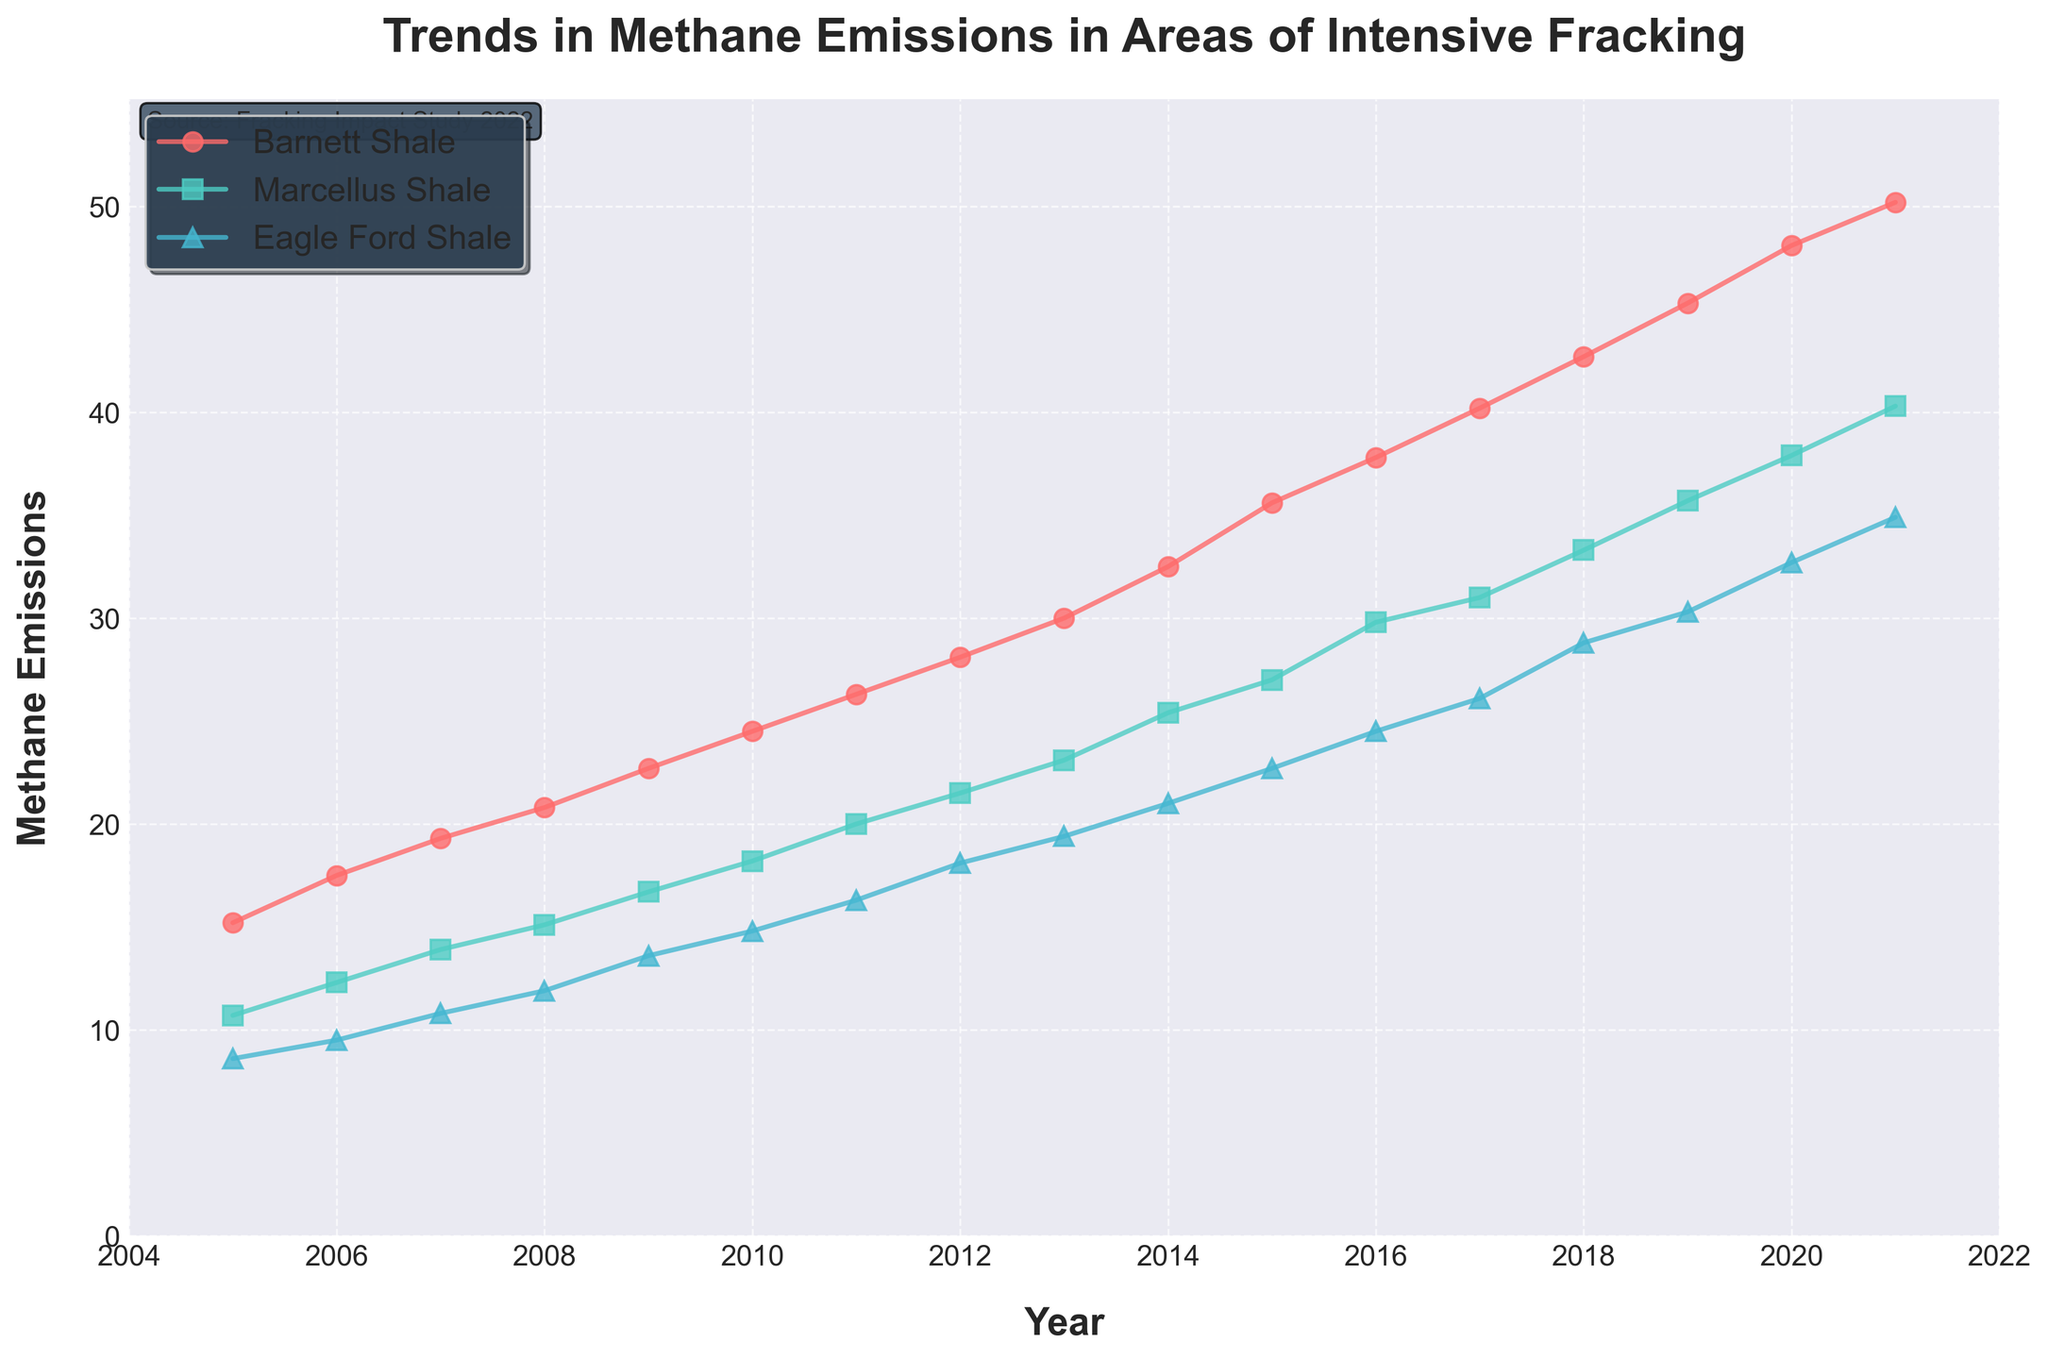What is the title of the plot? The title is located at the top center of the figure and is typically the most prominent text.
Answer: Trends in Methane Emissions in Areas of Intensive Fracking What are the x-axis and y-axis labels? The x-axis and y-axis labels are usually located beside the respective axes. They describe what each axis represents.
Answer: Year and Methane Emissions How does the methane emission trend for the Barnett Shale region change from 2005 to 2021? The trend for methane emissions in the Barnett Shale region can be observed by looking at the data points and the line connecting them. The emissions increase steadily every year.
Answer: It increases continuously Which region had the highest methane emissions in 2021? To determine which region had the highest methane emissions in 2021, compare the end points of each line representing each region on the plot. The Barnett Shale region shows the highest value at 2021.
Answer: Barnett Shale In which year did the Marcellus Shale region first exceed 20 units of methane emissions? Look at the plot for the Marcellus Shale line and check the year axis for when the line first crosses the 20 units mark on the y-axis. It occurs in 2011.
Answer: 2011 Compare the methane emissions between Eagle Ford Shale and Barnett Shale in 2010. Locate the methane emission values for both the Eagle Ford Shale and Barnett Shale lines in 2010 and compare them directly; Barnett Shale emissions are higher in that year.
Answer: Barnett Shale is higher What is the overall trend for methane emissions in the Eagle Ford Shale region from 2005 to 2021? Look at the entire line for the Eagle Ford Shale region from 2005 to 2021. The line shows a steady upward trend throughout the period.
Answer: Increasing How does the methane emission growth rate from 2005 to 2021 differ between Barnett Shale and Marcellus Shale? To ascertain the growth rate, observe the slope and length of the upward trend for both regions. Barnett Shale has a steeper slope compared to the Marcellus Shale, indicating a faster growth rate.
Answer: Barnett Shale grows faster What is the difference in methane emissions between Eagle Ford Shale and Marcellus Shale in 2021? Identify the value of methane emissions for both the Eagle Ford Shale and Marcellus Shale in 2021, then subtract the smaller value from the larger one. Eagle Ford: 34.9, Marcellus Shale: 40.3; the difference is 40.3 - 34.9.
Answer: 5.4 units How did methane emissions in the Barnett Shale region change from 2015 to 2020? Locate the data points for Barnett Shale in 2015 and 2020, then observe the change in values from one point to the other; it increases from 35.6 to 48.1.
Answer: Increased by 12.5 units 